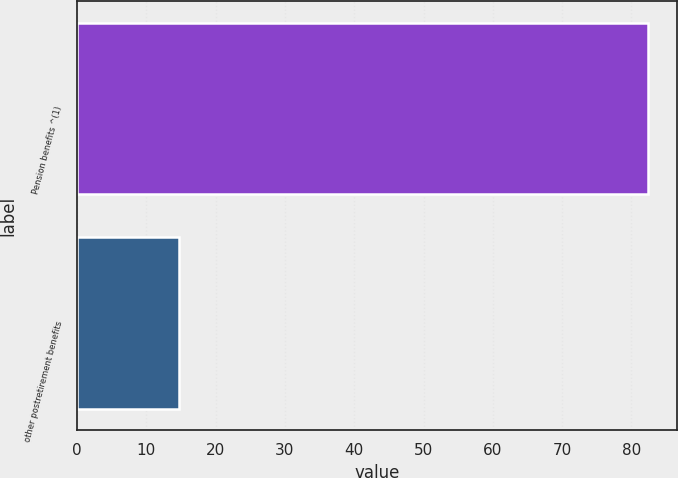Convert chart to OTSL. <chart><loc_0><loc_0><loc_500><loc_500><bar_chart><fcel>Pension benefits ^(1)<fcel>other postretirement benefits<nl><fcel>82.4<fcel>14.7<nl></chart> 